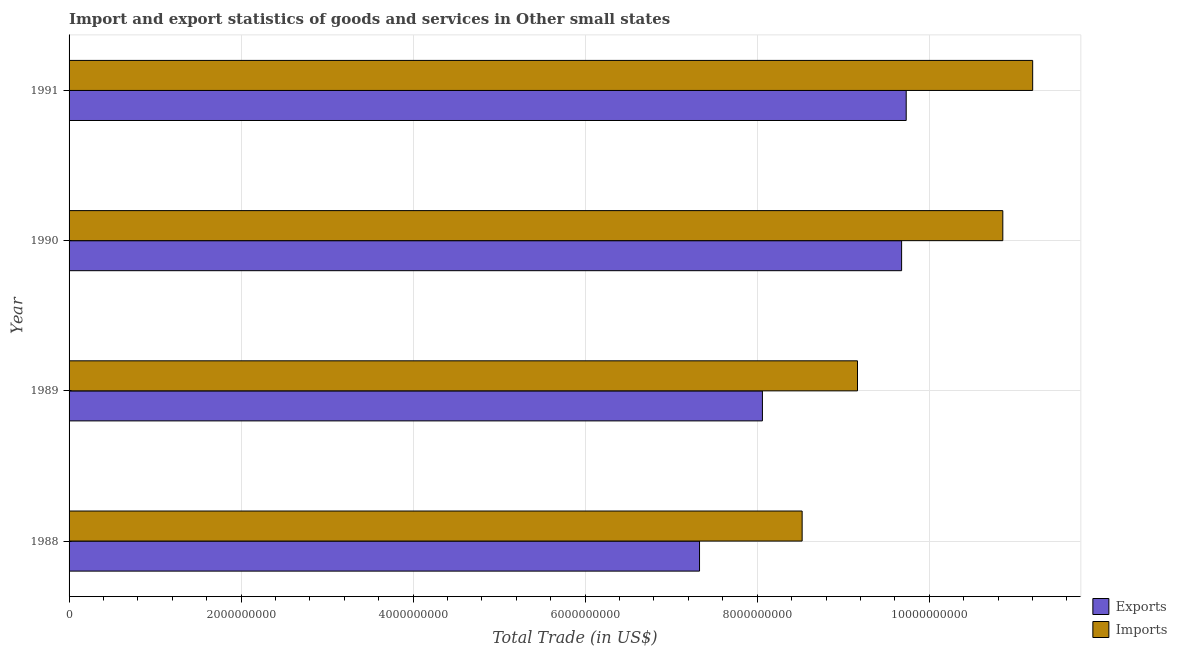How many different coloured bars are there?
Make the answer very short. 2. Are the number of bars per tick equal to the number of legend labels?
Provide a short and direct response. Yes. Are the number of bars on each tick of the Y-axis equal?
Your response must be concise. Yes. In how many cases, is the number of bars for a given year not equal to the number of legend labels?
Ensure brevity in your answer.  0. What is the imports of goods and services in 1989?
Your response must be concise. 9.17e+09. Across all years, what is the maximum export of goods and services?
Your answer should be compact. 9.73e+09. Across all years, what is the minimum export of goods and services?
Offer a very short reply. 7.33e+09. In which year was the export of goods and services minimum?
Your response must be concise. 1988. What is the total imports of goods and services in the graph?
Ensure brevity in your answer.  3.97e+1. What is the difference between the imports of goods and services in 1988 and that in 1991?
Your answer should be compact. -2.68e+09. What is the difference between the imports of goods and services in 1991 and the export of goods and services in 1989?
Give a very brief answer. 3.14e+09. What is the average export of goods and services per year?
Offer a terse response. 8.70e+09. In the year 1990, what is the difference between the export of goods and services and imports of goods and services?
Keep it short and to the point. -1.18e+09. In how many years, is the imports of goods and services greater than 400000000 US$?
Your answer should be very brief. 4. What is the ratio of the export of goods and services in 1990 to that in 1991?
Give a very brief answer. 0.99. Is the difference between the export of goods and services in 1988 and 1989 greater than the difference between the imports of goods and services in 1988 and 1989?
Offer a terse response. No. What is the difference between the highest and the second highest imports of goods and services?
Offer a terse response. 3.47e+08. What is the difference between the highest and the lowest export of goods and services?
Your response must be concise. 2.40e+09. Is the sum of the imports of goods and services in 1988 and 1989 greater than the maximum export of goods and services across all years?
Offer a very short reply. Yes. What does the 2nd bar from the top in 1991 represents?
Provide a succinct answer. Exports. What does the 2nd bar from the bottom in 1988 represents?
Provide a short and direct response. Imports. How many bars are there?
Ensure brevity in your answer.  8. Are all the bars in the graph horizontal?
Your response must be concise. Yes. Does the graph contain grids?
Your answer should be very brief. Yes. How many legend labels are there?
Your response must be concise. 2. What is the title of the graph?
Keep it short and to the point. Import and export statistics of goods and services in Other small states. Does "Central government" appear as one of the legend labels in the graph?
Your response must be concise. No. What is the label or title of the X-axis?
Offer a terse response. Total Trade (in US$). What is the label or title of the Y-axis?
Keep it short and to the point. Year. What is the Total Trade (in US$) of Exports in 1988?
Offer a terse response. 7.33e+09. What is the Total Trade (in US$) of Imports in 1988?
Your response must be concise. 8.52e+09. What is the Total Trade (in US$) in Exports in 1989?
Ensure brevity in your answer.  8.06e+09. What is the Total Trade (in US$) in Imports in 1989?
Your response must be concise. 9.17e+09. What is the Total Trade (in US$) in Exports in 1990?
Make the answer very short. 9.68e+09. What is the Total Trade (in US$) in Imports in 1990?
Your answer should be compact. 1.09e+1. What is the Total Trade (in US$) in Exports in 1991?
Make the answer very short. 9.73e+09. What is the Total Trade (in US$) in Imports in 1991?
Your response must be concise. 1.12e+1. Across all years, what is the maximum Total Trade (in US$) of Exports?
Ensure brevity in your answer.  9.73e+09. Across all years, what is the maximum Total Trade (in US$) in Imports?
Your response must be concise. 1.12e+1. Across all years, what is the minimum Total Trade (in US$) in Exports?
Your answer should be compact. 7.33e+09. Across all years, what is the minimum Total Trade (in US$) in Imports?
Make the answer very short. 8.52e+09. What is the total Total Trade (in US$) in Exports in the graph?
Provide a short and direct response. 3.48e+1. What is the total Total Trade (in US$) in Imports in the graph?
Ensure brevity in your answer.  3.97e+1. What is the difference between the Total Trade (in US$) of Exports in 1988 and that in 1989?
Keep it short and to the point. -7.31e+08. What is the difference between the Total Trade (in US$) in Imports in 1988 and that in 1989?
Your response must be concise. -6.44e+08. What is the difference between the Total Trade (in US$) in Exports in 1988 and that in 1990?
Provide a succinct answer. -2.35e+09. What is the difference between the Total Trade (in US$) in Imports in 1988 and that in 1990?
Your answer should be compact. -2.33e+09. What is the difference between the Total Trade (in US$) of Exports in 1988 and that in 1991?
Provide a short and direct response. -2.40e+09. What is the difference between the Total Trade (in US$) of Imports in 1988 and that in 1991?
Offer a terse response. -2.68e+09. What is the difference between the Total Trade (in US$) in Exports in 1989 and that in 1990?
Provide a succinct answer. -1.62e+09. What is the difference between the Total Trade (in US$) in Imports in 1989 and that in 1990?
Your answer should be very brief. -1.69e+09. What is the difference between the Total Trade (in US$) of Exports in 1989 and that in 1991?
Your response must be concise. -1.67e+09. What is the difference between the Total Trade (in US$) in Imports in 1989 and that in 1991?
Give a very brief answer. -2.04e+09. What is the difference between the Total Trade (in US$) of Exports in 1990 and that in 1991?
Give a very brief answer. -5.32e+07. What is the difference between the Total Trade (in US$) of Imports in 1990 and that in 1991?
Give a very brief answer. -3.47e+08. What is the difference between the Total Trade (in US$) of Exports in 1988 and the Total Trade (in US$) of Imports in 1989?
Offer a terse response. -1.84e+09. What is the difference between the Total Trade (in US$) of Exports in 1988 and the Total Trade (in US$) of Imports in 1990?
Your answer should be very brief. -3.53e+09. What is the difference between the Total Trade (in US$) in Exports in 1988 and the Total Trade (in US$) in Imports in 1991?
Your answer should be compact. -3.87e+09. What is the difference between the Total Trade (in US$) of Exports in 1989 and the Total Trade (in US$) of Imports in 1990?
Your response must be concise. -2.79e+09. What is the difference between the Total Trade (in US$) in Exports in 1989 and the Total Trade (in US$) in Imports in 1991?
Offer a very short reply. -3.14e+09. What is the difference between the Total Trade (in US$) in Exports in 1990 and the Total Trade (in US$) in Imports in 1991?
Your answer should be compact. -1.52e+09. What is the average Total Trade (in US$) of Exports per year?
Your response must be concise. 8.70e+09. What is the average Total Trade (in US$) of Imports per year?
Provide a succinct answer. 9.94e+09. In the year 1988, what is the difference between the Total Trade (in US$) in Exports and Total Trade (in US$) in Imports?
Offer a very short reply. -1.19e+09. In the year 1989, what is the difference between the Total Trade (in US$) of Exports and Total Trade (in US$) of Imports?
Offer a terse response. -1.11e+09. In the year 1990, what is the difference between the Total Trade (in US$) in Exports and Total Trade (in US$) in Imports?
Your answer should be very brief. -1.18e+09. In the year 1991, what is the difference between the Total Trade (in US$) in Exports and Total Trade (in US$) in Imports?
Your answer should be very brief. -1.47e+09. What is the ratio of the Total Trade (in US$) in Exports in 1988 to that in 1989?
Offer a very short reply. 0.91. What is the ratio of the Total Trade (in US$) in Imports in 1988 to that in 1989?
Provide a succinct answer. 0.93. What is the ratio of the Total Trade (in US$) in Exports in 1988 to that in 1990?
Ensure brevity in your answer.  0.76. What is the ratio of the Total Trade (in US$) of Imports in 1988 to that in 1990?
Provide a short and direct response. 0.79. What is the ratio of the Total Trade (in US$) in Exports in 1988 to that in 1991?
Offer a very short reply. 0.75. What is the ratio of the Total Trade (in US$) in Imports in 1988 to that in 1991?
Offer a terse response. 0.76. What is the ratio of the Total Trade (in US$) of Exports in 1989 to that in 1990?
Your response must be concise. 0.83. What is the ratio of the Total Trade (in US$) in Imports in 1989 to that in 1990?
Offer a terse response. 0.84. What is the ratio of the Total Trade (in US$) in Exports in 1989 to that in 1991?
Your answer should be very brief. 0.83. What is the ratio of the Total Trade (in US$) of Imports in 1989 to that in 1991?
Give a very brief answer. 0.82. What is the difference between the highest and the second highest Total Trade (in US$) of Exports?
Your answer should be compact. 5.32e+07. What is the difference between the highest and the second highest Total Trade (in US$) of Imports?
Your answer should be compact. 3.47e+08. What is the difference between the highest and the lowest Total Trade (in US$) of Exports?
Offer a terse response. 2.40e+09. What is the difference between the highest and the lowest Total Trade (in US$) in Imports?
Make the answer very short. 2.68e+09. 